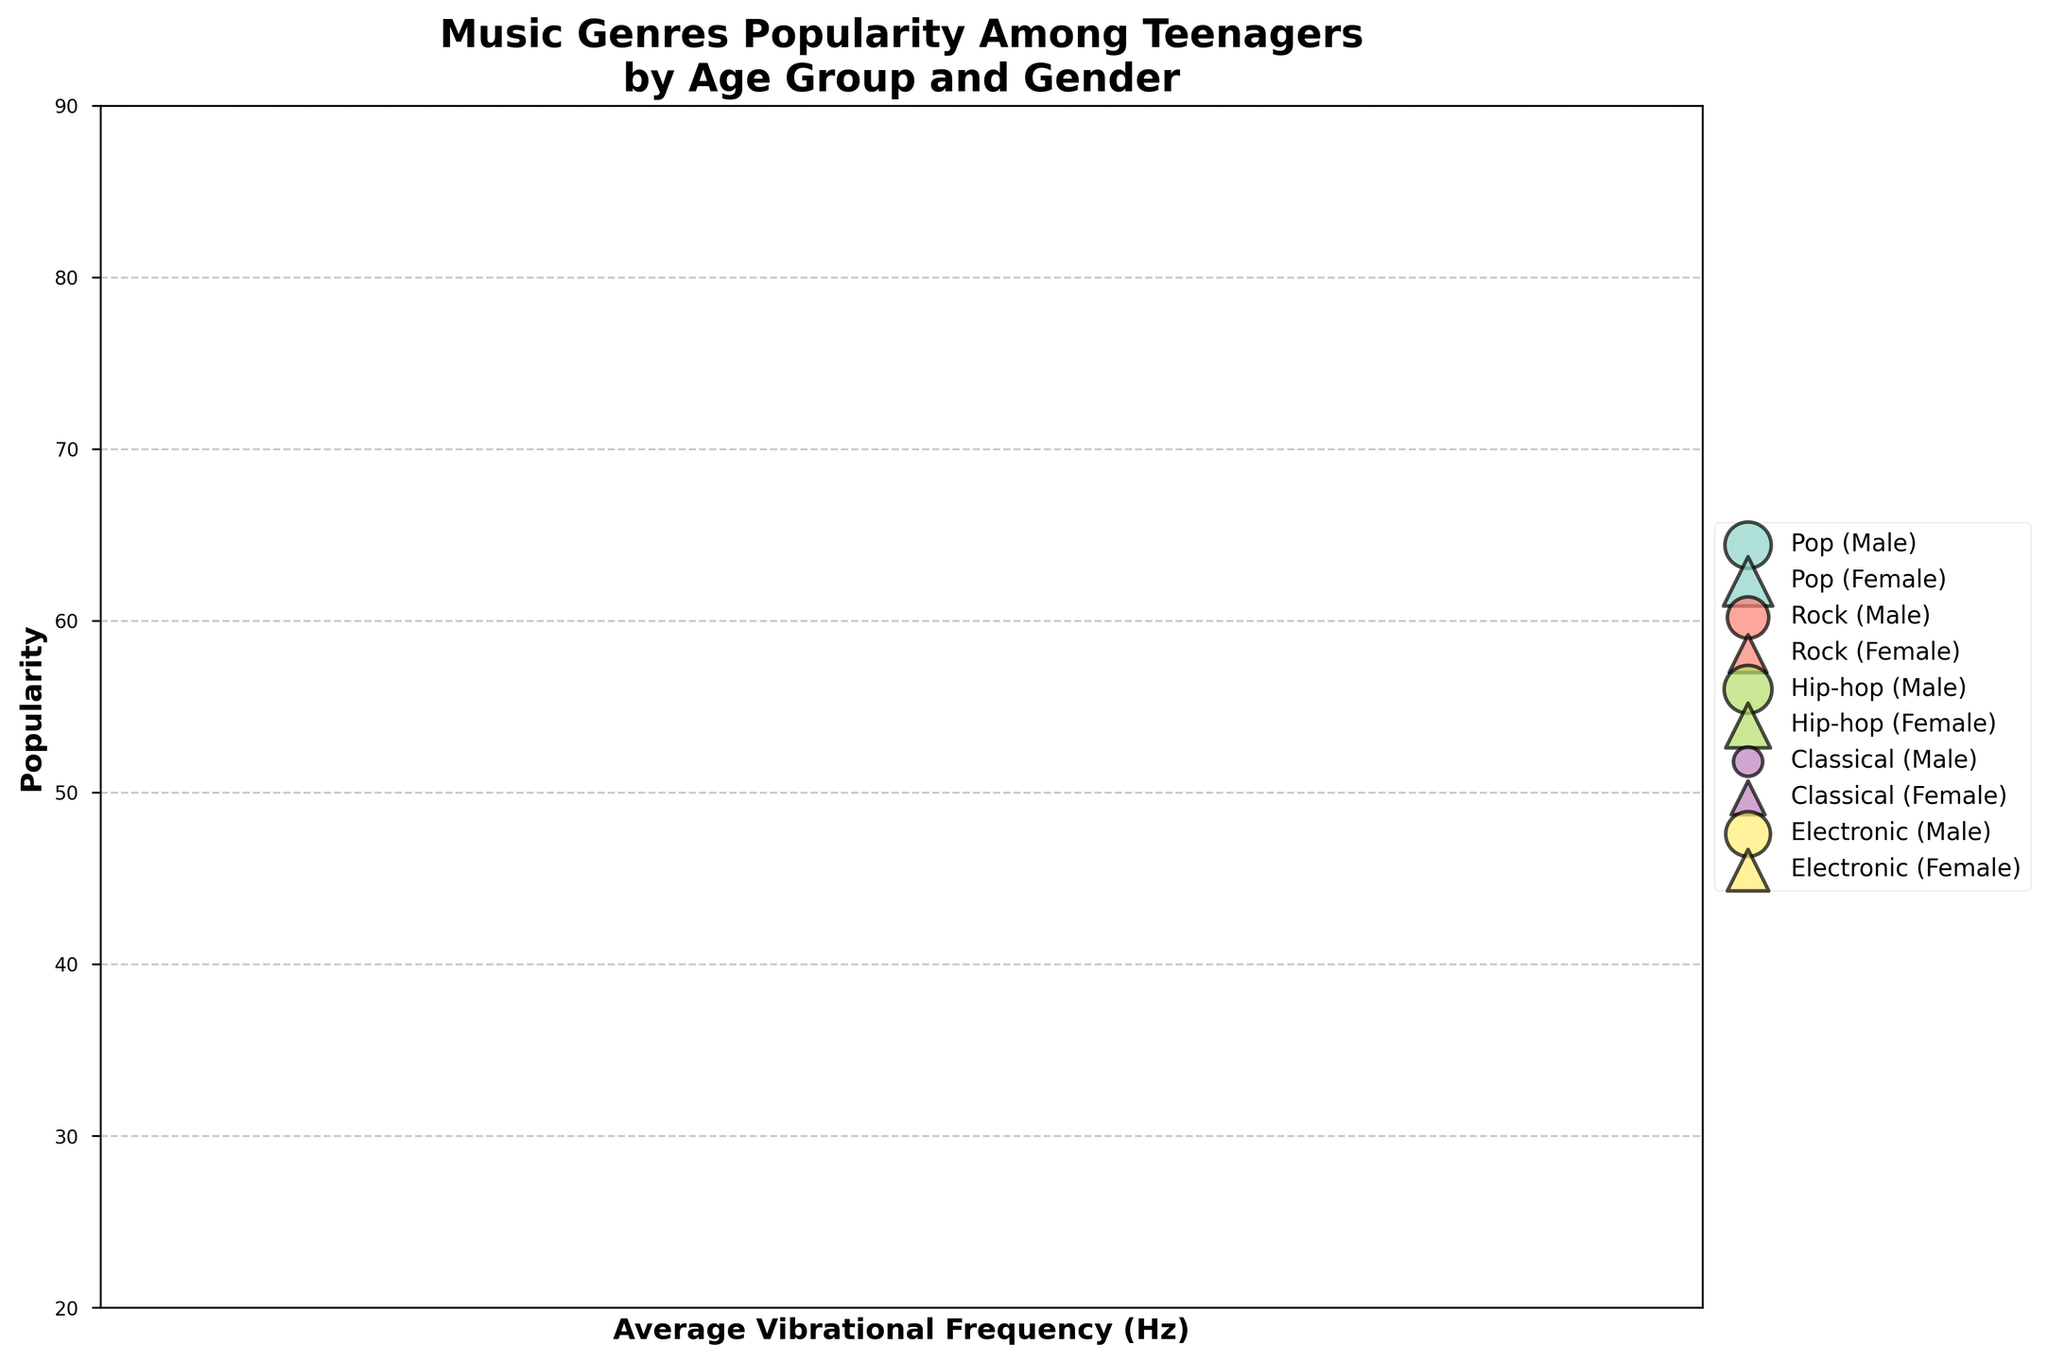What is the title of the figure? The title of the figure is usually found at the top and it gives a brief description of what the figure is about.
Answer: Music Genres Popularity Among Teenagers by Age Group and Gender How many unique music genres are represented in the chart? Count the different music genres shown in the legend of the figure.
Answer: 5 What is the average vibrational frequency for the Classical music genre? Locate the Classical music data points on the x-axis and observe that their vibrational frequency is consistent.
Answer: 110 Hz Which gender prefers Pop music more in the 13-15 age group? Look for the Pop music data points within the 13-15 age group and compare the size of the bubbles for males and females.
Answer: Female How does the popularity of Hip-hop among 16-18 males compare to 16-18 females? Compare the y-values of the bubbles for Hip-hop in the 16-18 age group for both males and females. Observe that the male bubble for Hip-hop is higher than the female bubble.
Answer: Higher for males What is the popularity difference between Rock and Classical music among 13-15 males? Find the y-values for the 13-15 male data points for Rock and Classical music, then compute the difference. 60 (Rock) - 30 (Classical) = 30
Answer: 30 Which music genre has the highest vibrational frequency, and what is it? Look for the bubble farthest to the right along the x-axis, which represents the highest vibrational frequency.
Answer: Electronic, 150 Hz Is there a music genre where its popularity is consistently higher for one gender across all age groups? Examine each genre's bubbles for both genders in both age groups. Hip-hop generally has higher popularity for males across both age groups.
Answer: Hip-hop What is the most popular music genre among 16-18 females? Identify the largest-sized bubble for 16-18 females by looking at the height and size of the bubbles along the y-axis.
Answer: Electronic Do any genres have a consistent vibrational frequency across all data points? Check the x-values for bubbles representing the same genre across all age and gender categories.
Answer: Pop, 120 Hz 